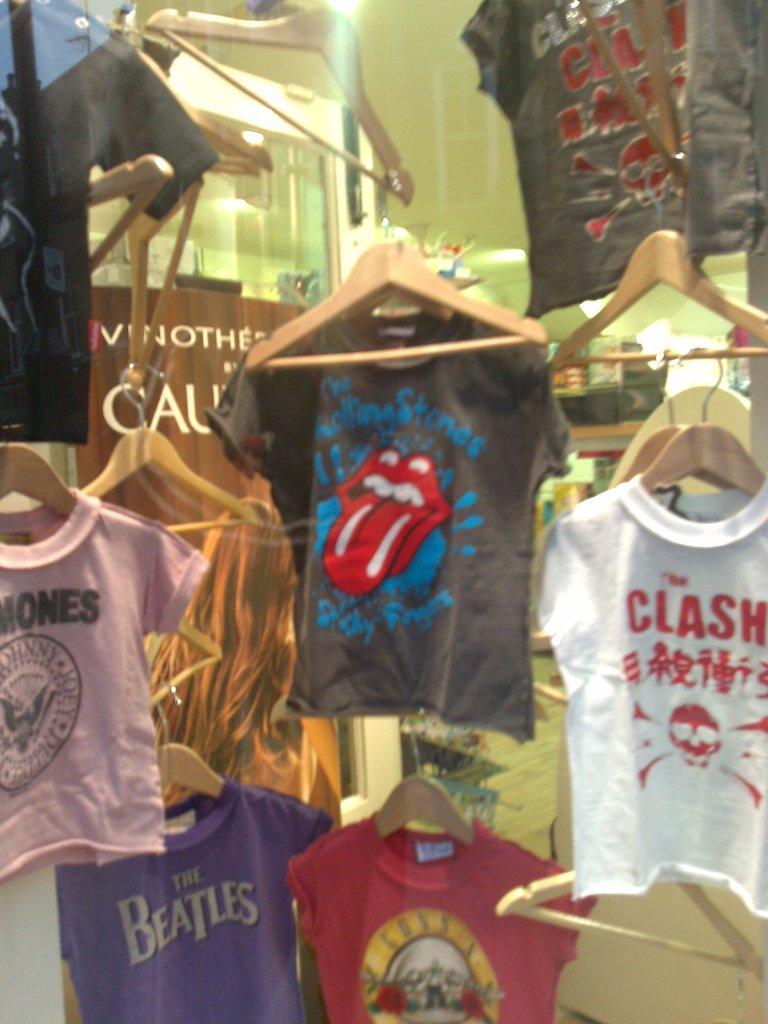In one or two sentences, can you explain what this image depicts? In the picture I can see clothes are hanging on hangers. In the background I can see some other objects. 